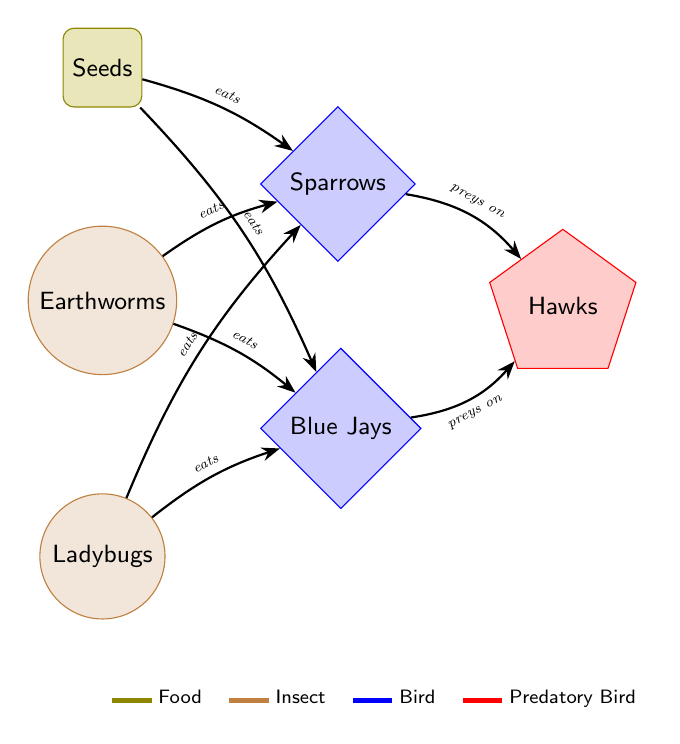What are the three insects depicted in the diagram? The diagram clearly shows ladybugs, earthworms, and seeds as the primary insects in the food chain.
Answer: Ladybugs, earthworms How many food types are represented in the chain? Upon reviewing the diagram, there are two categories explicitly labeled as food types: seeds and insects.
Answer: 2 Which birds eat ladybugs? The arrows indicate that sparrows and blue jays are consuming ladybugs as depicted in the diagram.
Answer: Sparrows, Blue Jays What type of bird preys on sparrows and blue jays? The diagram shows a predatory bird, identified as hawks, directly preying on both sparrows and blue jays through the connecting arrows.
Answer: Hawks What is the relationship between blue jays and earthworms? The diagram has an arrow pointing from earthworms to blue jays, indicating that blue jays eat earthworms.
Answer: Eats How many edges are there in total connecting the food chain? Counting the arrows, which represent connections, there are six edges linking the various nodes throughout the diagram.
Answer: 6 Describe the flow of energy from seeds to hawks. Seeds are consumed by sparrows and blue jays, which in turn are preyed upon by hawks, illustrating a direct flow of energy from seeds to hawks through these birds.
Answer: Seeds to Sparrows/Blue Jays to Hawks Which type of insect is not a food source for blue jays? The diagram shows that while blue jays eat both seeds and earthworms, ladybugs are represented as food exclusively for sparrows in this context.
Answer: None, all are food sources How many predatory birds are shown in the diagram? The diagram only features one type of predatory bird, which is labeled as hawks.
Answer: 1 